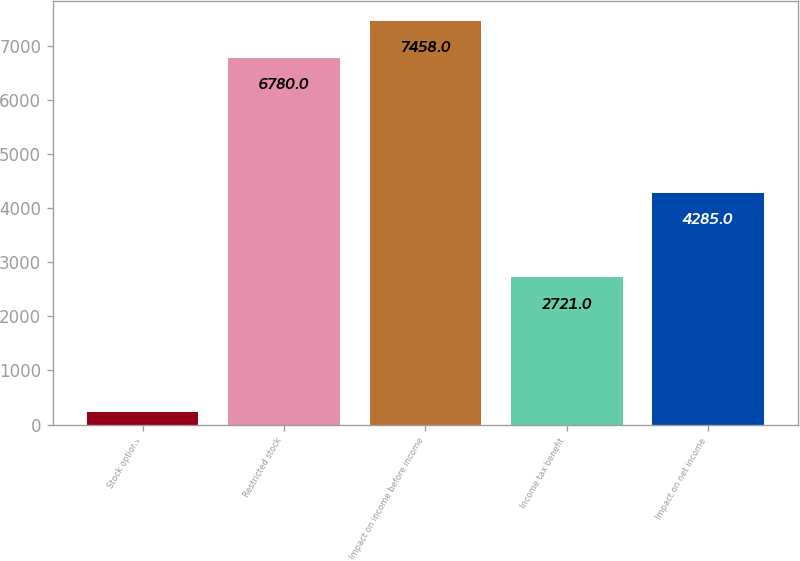Convert chart to OTSL. <chart><loc_0><loc_0><loc_500><loc_500><bar_chart><fcel>Stock options<fcel>Restricted stock<fcel>Impact on income before income<fcel>Income tax benefit<fcel>Impact on net income<nl><fcel>226<fcel>6780<fcel>7458<fcel>2721<fcel>4285<nl></chart> 